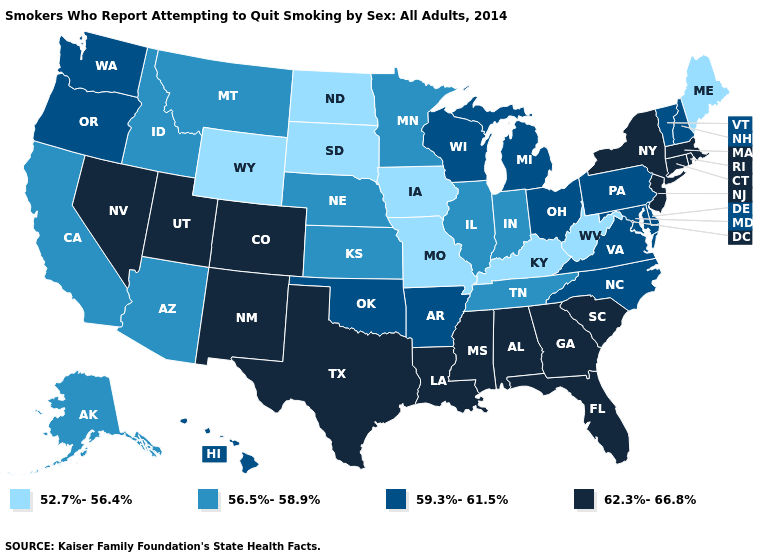Among the states that border Missouri , which have the lowest value?
Quick response, please. Iowa, Kentucky. Name the states that have a value in the range 62.3%-66.8%?
Write a very short answer. Alabama, Colorado, Connecticut, Florida, Georgia, Louisiana, Massachusetts, Mississippi, Nevada, New Jersey, New Mexico, New York, Rhode Island, South Carolina, Texas, Utah. Does Hawaii have a higher value than Minnesota?
Short answer required. Yes. Does New Jersey have the lowest value in the Northeast?
Answer briefly. No. What is the value of Kansas?
Keep it brief. 56.5%-58.9%. What is the value of Colorado?
Be succinct. 62.3%-66.8%. Does Maryland have the same value as Indiana?
Give a very brief answer. No. Which states have the highest value in the USA?
Quick response, please. Alabama, Colorado, Connecticut, Florida, Georgia, Louisiana, Massachusetts, Mississippi, Nevada, New Jersey, New Mexico, New York, Rhode Island, South Carolina, Texas, Utah. Name the states that have a value in the range 52.7%-56.4%?
Short answer required. Iowa, Kentucky, Maine, Missouri, North Dakota, South Dakota, West Virginia, Wyoming. What is the highest value in states that border Massachusetts?
Quick response, please. 62.3%-66.8%. Name the states that have a value in the range 52.7%-56.4%?
Write a very short answer. Iowa, Kentucky, Maine, Missouri, North Dakota, South Dakota, West Virginia, Wyoming. What is the lowest value in the USA?
Concise answer only. 52.7%-56.4%. Does Hawaii have a lower value than Minnesota?
Write a very short answer. No. Name the states that have a value in the range 52.7%-56.4%?
Short answer required. Iowa, Kentucky, Maine, Missouri, North Dakota, South Dakota, West Virginia, Wyoming. Which states have the lowest value in the USA?
Short answer required. Iowa, Kentucky, Maine, Missouri, North Dakota, South Dakota, West Virginia, Wyoming. 